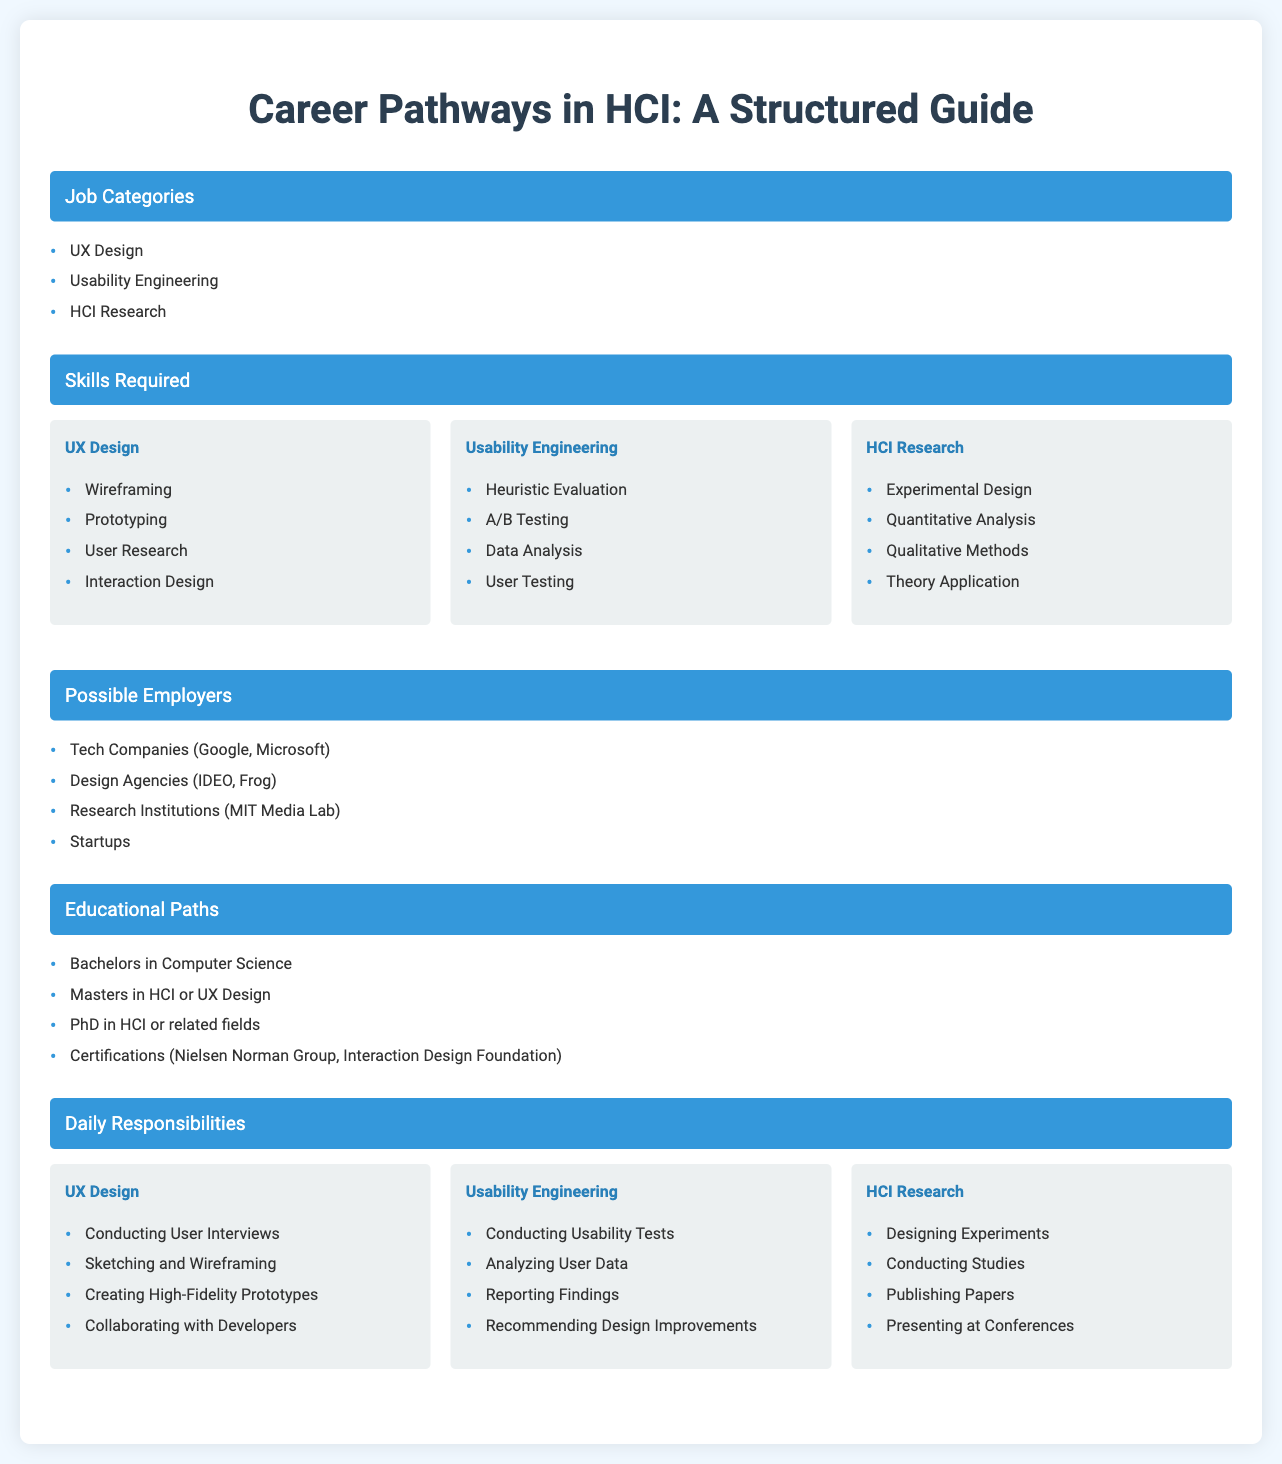what are the job categories listed in the document? The document lists three overarching job categories in HCI: UX Design, Usability Engineering, and HCI Research.
Answer: UX Design, Usability Engineering, HCI Research which section includes skills for UX design? The section on skills required contains a subsection specifically for UX Design, detailing various skills relevant to the role.
Answer: Skills Required name one possible employer for HCI professionals. The document outlines several potential employers; one example listed is tech companies like Google and Microsoft.
Answer: Tech Companies (Google, Microsoft) how many educational paths are mentioned in the document? The document outlines four distinct educational paths that individuals pursuing careers in HCI could take.
Answer: Four which daily responsibility involves analyzing user data? The daily responsibility related to usability engineering includes the task of analyzing user data.
Answer: Analyzing User Data what type of analysis is part of HCI research skills? Among the skills listed for HCI Research, quantitative analysis is specifically mentioned as a key skill required.
Answer: Quantitative Analysis what is the main focus of Usability Engineering? The main focus of Usability Engineering is centered around evaluating and improving the usability of products through various methods.
Answer: Usability Improvement name a certification path mentioned in the document. The document refers to certifications that can be obtained through institutions like the Nielsen Norman Group or the Interaction Design Foundation.
Answer: Nielsen Norman Group, Interaction Design Foundation 